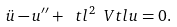Convert formula to latex. <formula><loc_0><loc_0><loc_500><loc_500>\ddot { u } - u ^ { \prime \prime } + \ t l ^ { 2 } \ V t l u = 0 .</formula> 